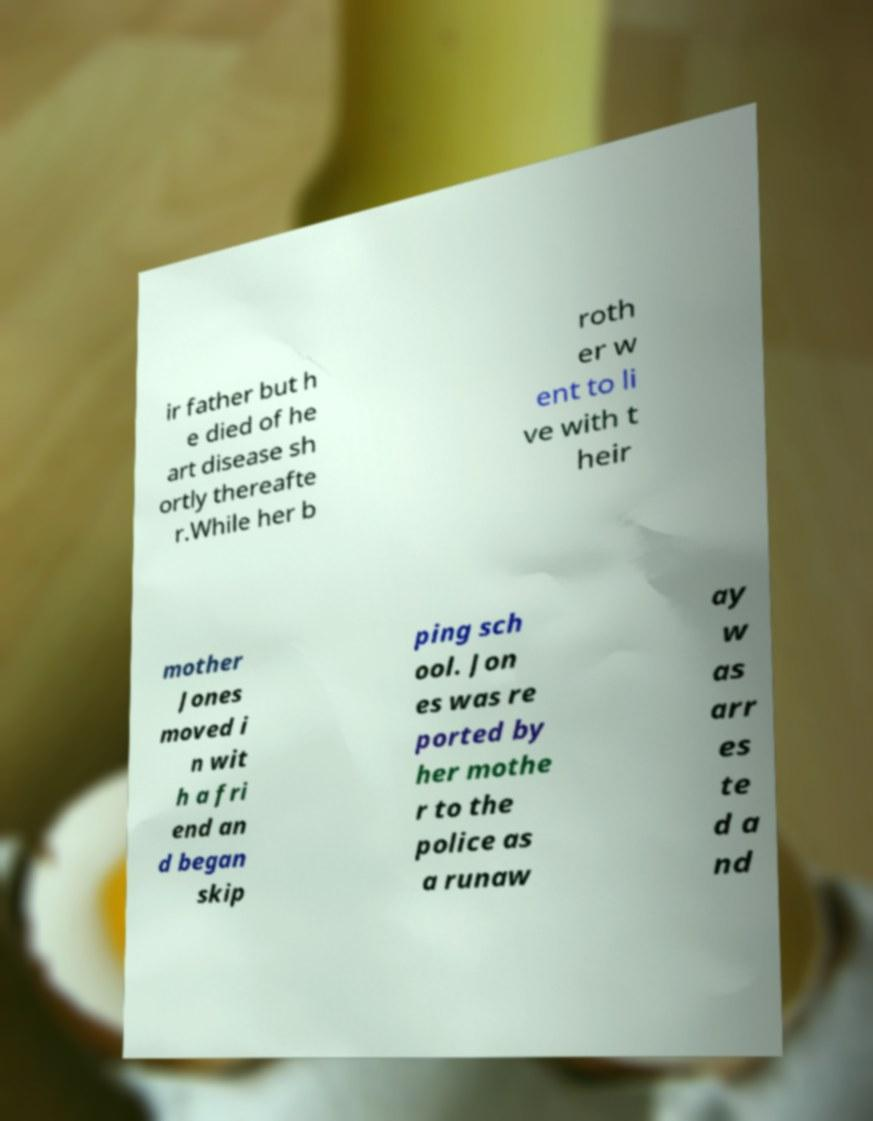Could you assist in decoding the text presented in this image and type it out clearly? ir father but h e died of he art disease sh ortly thereafte r.While her b roth er w ent to li ve with t heir mother Jones moved i n wit h a fri end an d began skip ping sch ool. Jon es was re ported by her mothe r to the police as a runaw ay w as arr es te d a nd 